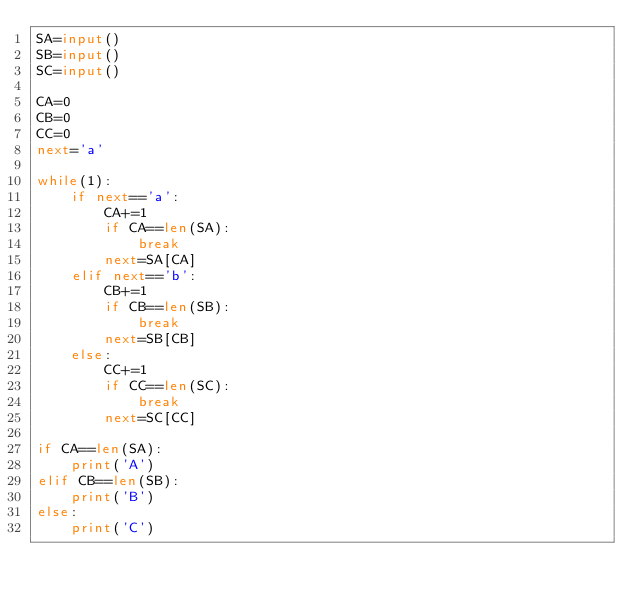<code> <loc_0><loc_0><loc_500><loc_500><_Python_>SA=input()
SB=input()
SC=input()

CA=0
CB=0
CC=0
next='a'

while(1):
    if next=='a':
        CA+=1
       	if CA==len(SA):
           	break
        next=SA[CA]
    elif next=='b':
        CB+=1
       	if CB==len(SB):
           	break
        next=SB[CB]
    else:
        CC+=1
       	if CC==len(SC):
           	break
        next=SC[CC]

if CA==len(SA):
    print('A')
elif CB==len(SB):
    print('B')
else:
    print('C')</code> 